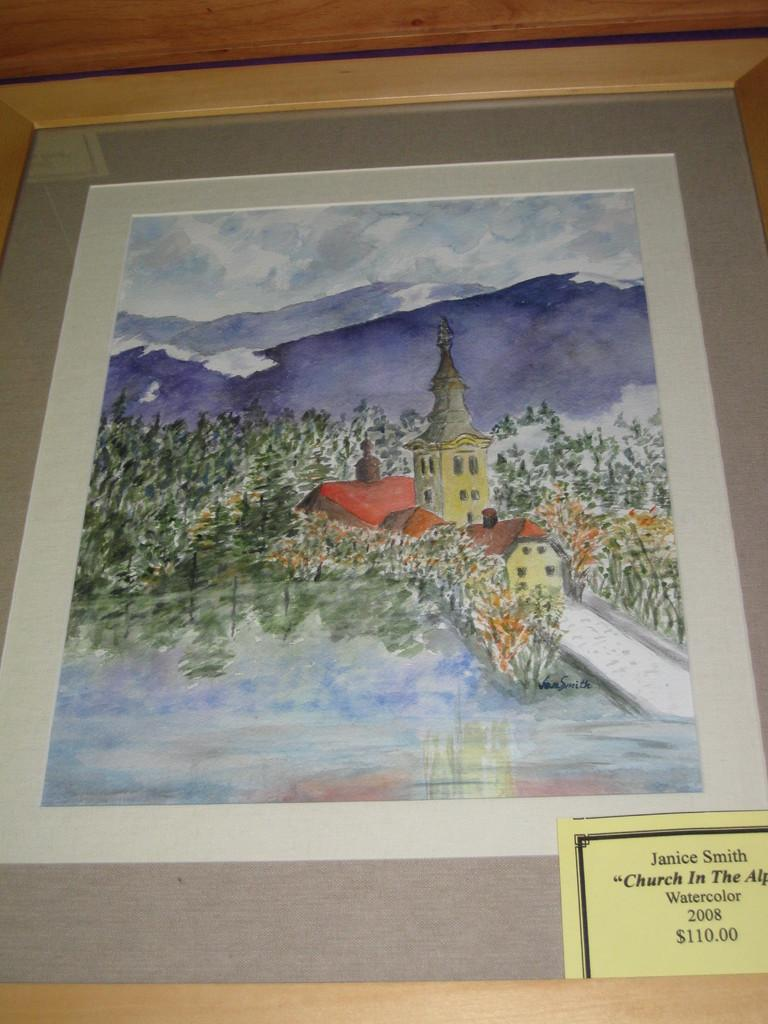<image>
Provide a brief description of the given image. Picture of a church that Janice Smith made using watercolor  called Church In the 